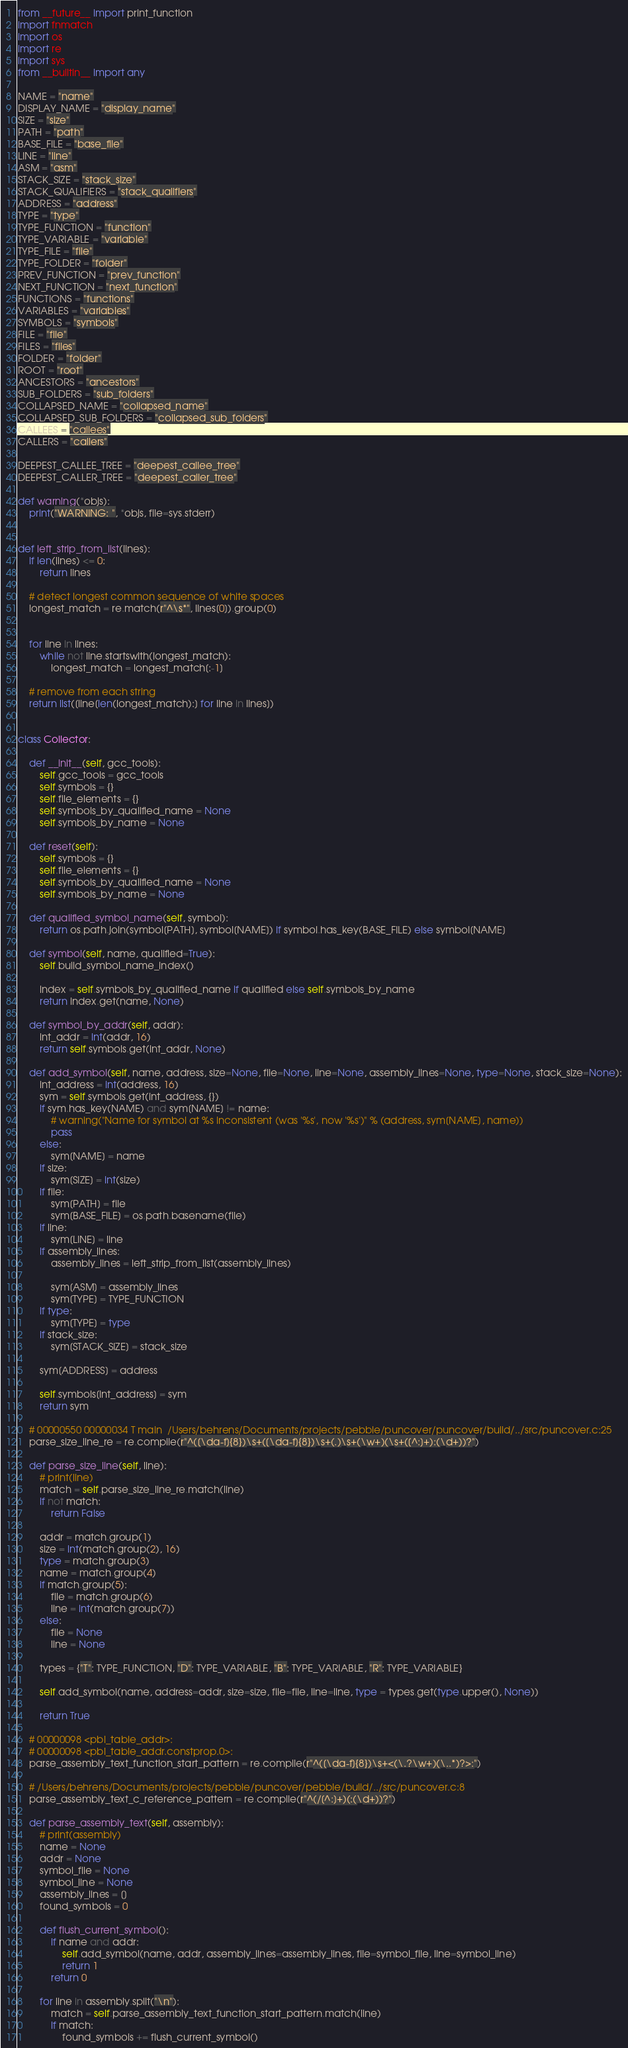<code> <loc_0><loc_0><loc_500><loc_500><_Python_>from __future__ import print_function
import fnmatch
import os
import re
import sys
from __builtin__ import any

NAME = "name"
DISPLAY_NAME = "display_name"
SIZE = "size"
PATH = "path"
BASE_FILE = "base_file"
LINE = "line"
ASM = "asm"
STACK_SIZE = "stack_size"
STACK_QUALIFIERS = "stack_qualifiers"
ADDRESS = "address"
TYPE = "type"
TYPE_FUNCTION = "function"
TYPE_VARIABLE = "variable"
TYPE_FILE = "file"
TYPE_FOLDER = "folder"
PREV_FUNCTION = "prev_function"
NEXT_FUNCTION = "next_function"
FUNCTIONS = "functions"
VARIABLES = "variables"
SYMBOLS = "symbols"
FILE = "file"
FILES = "files"
FOLDER = "folder"
ROOT = "root"
ANCESTORS = "ancestors"
SUB_FOLDERS = "sub_folders"
COLLAPSED_NAME = "collapsed_name"
COLLAPSED_SUB_FOLDERS = "collapsed_sub_folders"
CALLEES = "callees"
CALLERS = "callers"

DEEPEST_CALLEE_TREE = "deepest_callee_tree"
DEEPEST_CALLER_TREE = "deepest_caller_tree"

def warning(*objs):
    print("WARNING: ", *objs, file=sys.stderr)


def left_strip_from_list(lines):
    if len(lines) <= 0:
        return lines

    # detect longest common sequence of white spaces
    longest_match = re.match(r"^\s*", lines[0]).group(0)


    for line in lines:
        while not line.startswith(longest_match):
            longest_match = longest_match[:-1]

    # remove from each string
    return list([line[len(longest_match):] for line in lines])


class Collector:

    def __init__(self, gcc_tools):
        self.gcc_tools = gcc_tools
        self.symbols = {}
        self.file_elements = {}
        self.symbols_by_qualified_name = None
        self.symbols_by_name = None

    def reset(self):
        self.symbols = {}
        self.file_elements = {}
        self.symbols_by_qualified_name = None
        self.symbols_by_name = None

    def qualified_symbol_name(self, symbol):
        return os.path.join(symbol[PATH], symbol[NAME]) if symbol.has_key(BASE_FILE) else symbol[NAME]

    def symbol(self, name, qualified=True):
        self.build_symbol_name_index()

        index = self.symbols_by_qualified_name if qualified else self.symbols_by_name
        return index.get(name, None)

    def symbol_by_addr(self, addr):
        int_addr = int(addr, 16)
        return self.symbols.get(int_addr, None)

    def add_symbol(self, name, address, size=None, file=None, line=None, assembly_lines=None, type=None, stack_size=None):
        int_address = int(address, 16)
        sym = self.symbols.get(int_address, {})
        if sym.has_key(NAME) and sym[NAME] != name:
            # warning("Name for symbol at %s inconsistent (was '%s', now '%s')" % (address, sym[NAME], name))
            pass
        else:
            sym[NAME] = name
        if size:
            sym[SIZE] = int(size)
        if file:
            sym[PATH] = file
            sym[BASE_FILE] = os.path.basename(file)
        if line:
            sym[LINE] = line
        if assembly_lines:
            assembly_lines = left_strip_from_list(assembly_lines)

            sym[ASM] = assembly_lines
            sym[TYPE] = TYPE_FUNCTION
        if type:
            sym[TYPE] = type
        if stack_size:
            sym[STACK_SIZE] = stack_size

        sym[ADDRESS] = address

        self.symbols[int_address] = sym
        return sym

    # 00000550 00000034 T main	/Users/behrens/Documents/projects/pebble/puncover/puncover/build/../src/puncover.c:25
    parse_size_line_re = re.compile(r"^([\da-f]{8})\s+([\da-f]{8})\s+(.)\s+(\w+)(\s+([^:]+):(\d+))?")

    def parse_size_line(self, line):
        # print(line)
        match = self.parse_size_line_re.match(line)
        if not match:
            return False

        addr = match.group(1)
        size = int(match.group(2), 16)
        type = match.group(3)
        name = match.group(4)
        if match.group(5):
            file = match.group(6)
            line = int(match.group(7))
        else:
            file = None
            line = None

        types = {"T": TYPE_FUNCTION, "D": TYPE_VARIABLE, "B": TYPE_VARIABLE, "R": TYPE_VARIABLE}

        self.add_symbol(name, address=addr, size=size, file=file, line=line, type = types.get(type.upper(), None))

        return True

    # 00000098 <pbl_table_addr>:
    # 00000098 <pbl_table_addr.constprop.0>:
    parse_assembly_text_function_start_pattern = re.compile(r"^([\da-f]{8})\s+<(\.?\w+)(\..*)?>:")

    # /Users/behrens/Documents/projects/pebble/puncover/pebble/build/../src/puncover.c:8
    parse_assembly_text_c_reference_pattern = re.compile(r"^(/[^:]+)(:(\d+))?")

    def parse_assembly_text(self, assembly):
        # print(assembly)
        name = None
        addr = None
        symbol_file = None
        symbol_line = None
        assembly_lines = []
        found_symbols = 0

        def flush_current_symbol():
            if name and addr:
                self.add_symbol(name, addr, assembly_lines=assembly_lines, file=symbol_file, line=symbol_line)
                return 1
            return 0

        for line in assembly.split("\n"):
            match = self.parse_assembly_text_function_start_pattern.match(line)
            if match:
                found_symbols += flush_current_symbol()</code> 